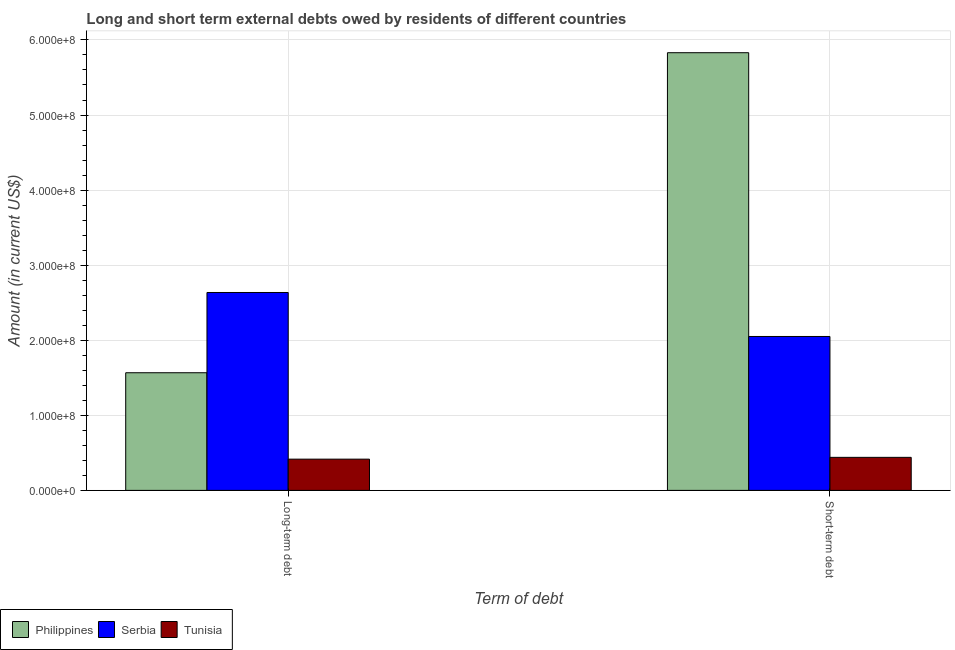How many different coloured bars are there?
Your response must be concise. 3. Are the number of bars per tick equal to the number of legend labels?
Offer a very short reply. Yes. How many bars are there on the 1st tick from the left?
Make the answer very short. 3. What is the label of the 1st group of bars from the left?
Offer a terse response. Long-term debt. What is the long-term debts owed by residents in Philippines?
Ensure brevity in your answer.  1.57e+08. Across all countries, what is the maximum long-term debts owed by residents?
Your answer should be very brief. 2.64e+08. Across all countries, what is the minimum short-term debts owed by residents?
Offer a very short reply. 4.40e+07. In which country was the long-term debts owed by residents maximum?
Give a very brief answer. Serbia. In which country was the short-term debts owed by residents minimum?
Offer a very short reply. Tunisia. What is the total short-term debts owed by residents in the graph?
Offer a very short reply. 8.32e+08. What is the difference between the long-term debts owed by residents in Tunisia and that in Serbia?
Your answer should be compact. -2.22e+08. What is the difference between the long-term debts owed by residents in Serbia and the short-term debts owed by residents in Tunisia?
Make the answer very short. 2.20e+08. What is the average long-term debts owed by residents per country?
Provide a short and direct response. 1.54e+08. What is the difference between the short-term debts owed by residents and long-term debts owed by residents in Serbia?
Your response must be concise. -5.86e+07. In how many countries, is the short-term debts owed by residents greater than 480000000 US$?
Your answer should be very brief. 1. What is the ratio of the short-term debts owed by residents in Serbia to that in Tunisia?
Give a very brief answer. 4.66. In how many countries, is the long-term debts owed by residents greater than the average long-term debts owed by residents taken over all countries?
Provide a succinct answer. 2. What does the 3rd bar from the left in Long-term debt represents?
Give a very brief answer. Tunisia. What does the 1st bar from the right in Long-term debt represents?
Your response must be concise. Tunisia. How many countries are there in the graph?
Ensure brevity in your answer.  3. What is the difference between two consecutive major ticks on the Y-axis?
Provide a short and direct response. 1.00e+08. Are the values on the major ticks of Y-axis written in scientific E-notation?
Make the answer very short. Yes. How many legend labels are there?
Your response must be concise. 3. How are the legend labels stacked?
Provide a short and direct response. Horizontal. What is the title of the graph?
Offer a very short reply. Long and short term external debts owed by residents of different countries. What is the label or title of the X-axis?
Make the answer very short. Term of debt. What is the Amount (in current US$) in Philippines in Long-term debt?
Your answer should be compact. 1.57e+08. What is the Amount (in current US$) of Serbia in Long-term debt?
Give a very brief answer. 2.64e+08. What is the Amount (in current US$) of Tunisia in Long-term debt?
Ensure brevity in your answer.  4.16e+07. What is the Amount (in current US$) of Philippines in Short-term debt?
Give a very brief answer. 5.83e+08. What is the Amount (in current US$) of Serbia in Short-term debt?
Give a very brief answer. 2.05e+08. What is the Amount (in current US$) of Tunisia in Short-term debt?
Make the answer very short. 4.40e+07. Across all Term of debt, what is the maximum Amount (in current US$) in Philippines?
Provide a succinct answer. 5.83e+08. Across all Term of debt, what is the maximum Amount (in current US$) of Serbia?
Your response must be concise. 2.64e+08. Across all Term of debt, what is the maximum Amount (in current US$) of Tunisia?
Offer a terse response. 4.40e+07. Across all Term of debt, what is the minimum Amount (in current US$) of Philippines?
Your answer should be very brief. 1.57e+08. Across all Term of debt, what is the minimum Amount (in current US$) in Serbia?
Offer a terse response. 2.05e+08. Across all Term of debt, what is the minimum Amount (in current US$) in Tunisia?
Provide a succinct answer. 4.16e+07. What is the total Amount (in current US$) of Philippines in the graph?
Offer a very short reply. 7.40e+08. What is the total Amount (in current US$) in Serbia in the graph?
Ensure brevity in your answer.  4.69e+08. What is the total Amount (in current US$) of Tunisia in the graph?
Offer a terse response. 8.56e+07. What is the difference between the Amount (in current US$) in Philippines in Long-term debt and that in Short-term debt?
Keep it short and to the point. -4.26e+08. What is the difference between the Amount (in current US$) in Serbia in Long-term debt and that in Short-term debt?
Your response must be concise. 5.86e+07. What is the difference between the Amount (in current US$) of Tunisia in Long-term debt and that in Short-term debt?
Keep it short and to the point. -2.40e+06. What is the difference between the Amount (in current US$) of Philippines in Long-term debt and the Amount (in current US$) of Serbia in Short-term debt?
Your answer should be very brief. -4.83e+07. What is the difference between the Amount (in current US$) in Philippines in Long-term debt and the Amount (in current US$) in Tunisia in Short-term debt?
Provide a succinct answer. 1.13e+08. What is the difference between the Amount (in current US$) of Serbia in Long-term debt and the Amount (in current US$) of Tunisia in Short-term debt?
Give a very brief answer. 2.20e+08. What is the average Amount (in current US$) in Philippines per Term of debt?
Give a very brief answer. 3.70e+08. What is the average Amount (in current US$) in Serbia per Term of debt?
Provide a succinct answer. 2.34e+08. What is the average Amount (in current US$) of Tunisia per Term of debt?
Provide a short and direct response. 4.28e+07. What is the difference between the Amount (in current US$) in Philippines and Amount (in current US$) in Serbia in Long-term debt?
Provide a succinct answer. -1.07e+08. What is the difference between the Amount (in current US$) of Philippines and Amount (in current US$) of Tunisia in Long-term debt?
Provide a succinct answer. 1.15e+08. What is the difference between the Amount (in current US$) in Serbia and Amount (in current US$) in Tunisia in Long-term debt?
Offer a very short reply. 2.22e+08. What is the difference between the Amount (in current US$) of Philippines and Amount (in current US$) of Serbia in Short-term debt?
Offer a terse response. 3.78e+08. What is the difference between the Amount (in current US$) of Philippines and Amount (in current US$) of Tunisia in Short-term debt?
Ensure brevity in your answer.  5.39e+08. What is the difference between the Amount (in current US$) of Serbia and Amount (in current US$) of Tunisia in Short-term debt?
Keep it short and to the point. 1.61e+08. What is the ratio of the Amount (in current US$) of Philippines in Long-term debt to that in Short-term debt?
Ensure brevity in your answer.  0.27. What is the ratio of the Amount (in current US$) in Serbia in Long-term debt to that in Short-term debt?
Provide a succinct answer. 1.29. What is the ratio of the Amount (in current US$) of Tunisia in Long-term debt to that in Short-term debt?
Offer a very short reply. 0.95. What is the difference between the highest and the second highest Amount (in current US$) in Philippines?
Make the answer very short. 4.26e+08. What is the difference between the highest and the second highest Amount (in current US$) of Serbia?
Ensure brevity in your answer.  5.86e+07. What is the difference between the highest and the second highest Amount (in current US$) of Tunisia?
Give a very brief answer. 2.40e+06. What is the difference between the highest and the lowest Amount (in current US$) of Philippines?
Make the answer very short. 4.26e+08. What is the difference between the highest and the lowest Amount (in current US$) of Serbia?
Provide a short and direct response. 5.86e+07. What is the difference between the highest and the lowest Amount (in current US$) of Tunisia?
Ensure brevity in your answer.  2.40e+06. 